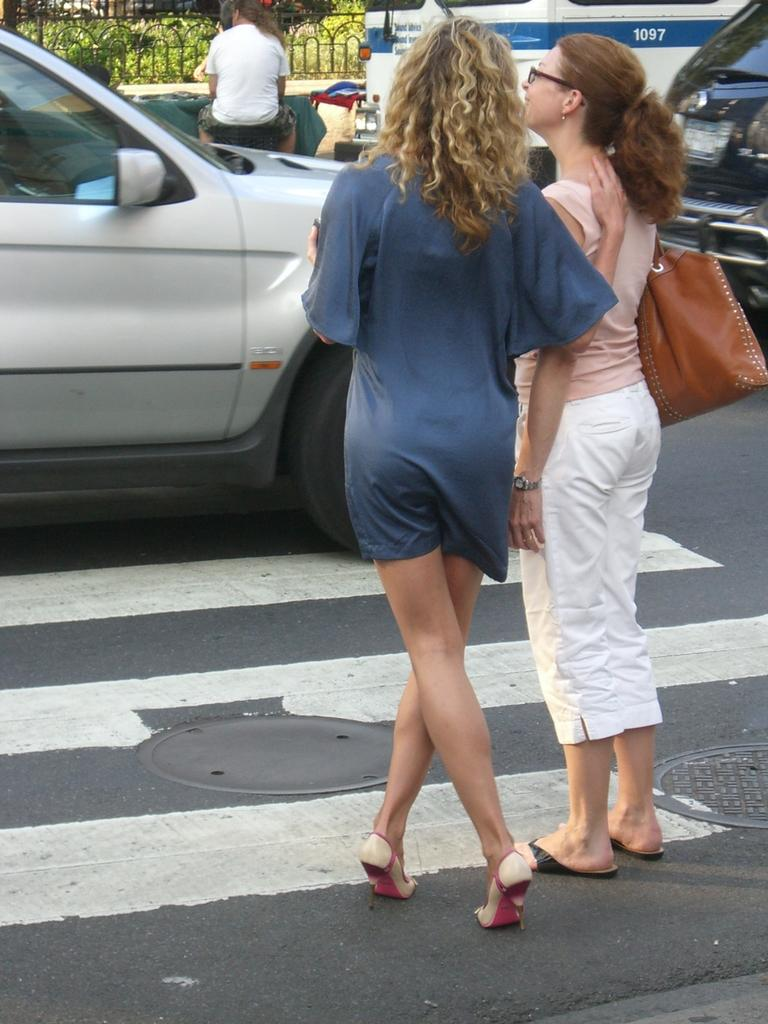What can be seen in the image? There are vehicles and two women standing on the road in the image. Can you describe the vehicles in the image? Unfortunately, the facts provided do not give any specific details about the vehicles. What are the women doing in the image? The facts provided do not give any specific details about the women's actions or activities. Where is the fork placed in the image? There is no fork present in the image. Is the parcel being delivered by one of the women in the image? There is no mention of a parcel in the image, so it cannot be determined if one of the women is delivering it. What type of office can be seen in the background of the image? There is no office present in the image; it only shows vehicles and two women standing on the road. 